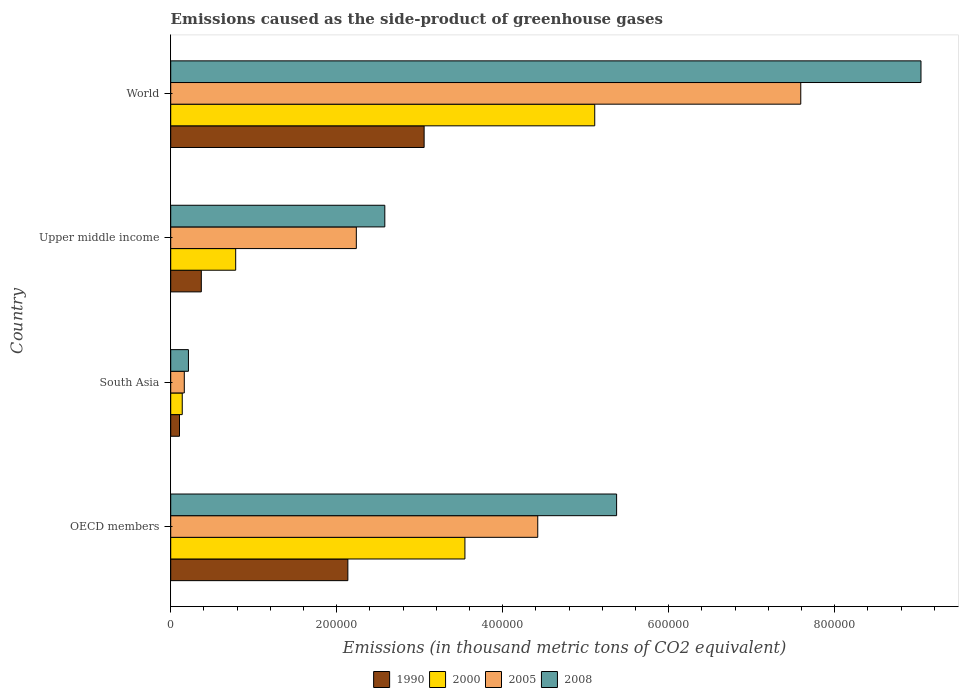How many different coloured bars are there?
Your answer should be very brief. 4. How many groups of bars are there?
Your response must be concise. 4. Are the number of bars on each tick of the Y-axis equal?
Your answer should be very brief. Yes. How many bars are there on the 2nd tick from the top?
Offer a very short reply. 4. What is the emissions caused as the side-product of greenhouse gases in 2000 in World?
Give a very brief answer. 5.11e+05. Across all countries, what is the maximum emissions caused as the side-product of greenhouse gases in 1990?
Keep it short and to the point. 3.05e+05. Across all countries, what is the minimum emissions caused as the side-product of greenhouse gases in 2005?
Provide a short and direct response. 1.64e+04. What is the total emissions caused as the side-product of greenhouse gases in 2000 in the graph?
Make the answer very short. 9.58e+05. What is the difference between the emissions caused as the side-product of greenhouse gases in 1990 in Upper middle income and that in World?
Your answer should be compact. -2.68e+05. What is the difference between the emissions caused as the side-product of greenhouse gases in 2005 in South Asia and the emissions caused as the side-product of greenhouse gases in 1990 in Upper middle income?
Keep it short and to the point. -2.05e+04. What is the average emissions caused as the side-product of greenhouse gases in 2005 per country?
Provide a short and direct response. 3.60e+05. What is the difference between the emissions caused as the side-product of greenhouse gases in 2008 and emissions caused as the side-product of greenhouse gases in 2000 in South Asia?
Ensure brevity in your answer.  7460.6. In how many countries, is the emissions caused as the side-product of greenhouse gases in 1990 greater than 680000 thousand metric tons?
Your answer should be compact. 0. What is the ratio of the emissions caused as the side-product of greenhouse gases in 2005 in South Asia to that in World?
Your answer should be very brief. 0.02. What is the difference between the highest and the second highest emissions caused as the side-product of greenhouse gases in 2005?
Give a very brief answer. 3.17e+05. What is the difference between the highest and the lowest emissions caused as the side-product of greenhouse gases in 1990?
Offer a very short reply. 2.95e+05. In how many countries, is the emissions caused as the side-product of greenhouse gases in 1990 greater than the average emissions caused as the side-product of greenhouse gases in 1990 taken over all countries?
Provide a succinct answer. 2. Is the sum of the emissions caused as the side-product of greenhouse gases in 2008 in OECD members and World greater than the maximum emissions caused as the side-product of greenhouse gases in 2000 across all countries?
Your answer should be compact. Yes. What does the 1st bar from the top in OECD members represents?
Keep it short and to the point. 2008. What does the 4th bar from the bottom in Upper middle income represents?
Offer a very short reply. 2008. Is it the case that in every country, the sum of the emissions caused as the side-product of greenhouse gases in 1990 and emissions caused as the side-product of greenhouse gases in 2000 is greater than the emissions caused as the side-product of greenhouse gases in 2005?
Keep it short and to the point. No. How many bars are there?
Give a very brief answer. 16. Are all the bars in the graph horizontal?
Keep it short and to the point. Yes. How many countries are there in the graph?
Make the answer very short. 4. Does the graph contain any zero values?
Keep it short and to the point. No. Where does the legend appear in the graph?
Make the answer very short. Bottom center. How are the legend labels stacked?
Your answer should be compact. Horizontal. What is the title of the graph?
Your answer should be compact. Emissions caused as the side-product of greenhouse gases. Does "1976" appear as one of the legend labels in the graph?
Make the answer very short. No. What is the label or title of the X-axis?
Give a very brief answer. Emissions (in thousand metric tons of CO2 equivalent). What is the Emissions (in thousand metric tons of CO2 equivalent) of 1990 in OECD members?
Your answer should be very brief. 2.13e+05. What is the Emissions (in thousand metric tons of CO2 equivalent) of 2000 in OECD members?
Offer a very short reply. 3.54e+05. What is the Emissions (in thousand metric tons of CO2 equivalent) in 2005 in OECD members?
Provide a succinct answer. 4.42e+05. What is the Emissions (in thousand metric tons of CO2 equivalent) of 2008 in OECD members?
Your answer should be compact. 5.37e+05. What is the Emissions (in thousand metric tons of CO2 equivalent) of 1990 in South Asia?
Ensure brevity in your answer.  1.06e+04. What is the Emissions (in thousand metric tons of CO2 equivalent) of 2000 in South Asia?
Your answer should be very brief. 1.39e+04. What is the Emissions (in thousand metric tons of CO2 equivalent) in 2005 in South Asia?
Provide a succinct answer. 1.64e+04. What is the Emissions (in thousand metric tons of CO2 equivalent) of 2008 in South Asia?
Keep it short and to the point. 2.14e+04. What is the Emissions (in thousand metric tons of CO2 equivalent) in 1990 in Upper middle income?
Your response must be concise. 3.69e+04. What is the Emissions (in thousand metric tons of CO2 equivalent) in 2000 in Upper middle income?
Your answer should be very brief. 7.83e+04. What is the Emissions (in thousand metric tons of CO2 equivalent) in 2005 in Upper middle income?
Keep it short and to the point. 2.24e+05. What is the Emissions (in thousand metric tons of CO2 equivalent) in 2008 in Upper middle income?
Give a very brief answer. 2.58e+05. What is the Emissions (in thousand metric tons of CO2 equivalent) in 1990 in World?
Your answer should be compact. 3.05e+05. What is the Emissions (in thousand metric tons of CO2 equivalent) of 2000 in World?
Offer a terse response. 5.11e+05. What is the Emissions (in thousand metric tons of CO2 equivalent) in 2005 in World?
Your answer should be compact. 7.59e+05. What is the Emissions (in thousand metric tons of CO2 equivalent) in 2008 in World?
Your answer should be very brief. 9.04e+05. Across all countries, what is the maximum Emissions (in thousand metric tons of CO2 equivalent) in 1990?
Offer a very short reply. 3.05e+05. Across all countries, what is the maximum Emissions (in thousand metric tons of CO2 equivalent) in 2000?
Keep it short and to the point. 5.11e+05. Across all countries, what is the maximum Emissions (in thousand metric tons of CO2 equivalent) in 2005?
Provide a succinct answer. 7.59e+05. Across all countries, what is the maximum Emissions (in thousand metric tons of CO2 equivalent) in 2008?
Your answer should be very brief. 9.04e+05. Across all countries, what is the minimum Emissions (in thousand metric tons of CO2 equivalent) of 1990?
Ensure brevity in your answer.  1.06e+04. Across all countries, what is the minimum Emissions (in thousand metric tons of CO2 equivalent) of 2000?
Keep it short and to the point. 1.39e+04. Across all countries, what is the minimum Emissions (in thousand metric tons of CO2 equivalent) in 2005?
Give a very brief answer. 1.64e+04. Across all countries, what is the minimum Emissions (in thousand metric tons of CO2 equivalent) in 2008?
Your response must be concise. 2.14e+04. What is the total Emissions (in thousand metric tons of CO2 equivalent) in 1990 in the graph?
Your answer should be compact. 5.66e+05. What is the total Emissions (in thousand metric tons of CO2 equivalent) of 2000 in the graph?
Give a very brief answer. 9.58e+05. What is the total Emissions (in thousand metric tons of CO2 equivalent) in 2005 in the graph?
Your answer should be very brief. 1.44e+06. What is the total Emissions (in thousand metric tons of CO2 equivalent) in 2008 in the graph?
Give a very brief answer. 1.72e+06. What is the difference between the Emissions (in thousand metric tons of CO2 equivalent) of 1990 in OECD members and that in South Asia?
Your answer should be very brief. 2.03e+05. What is the difference between the Emissions (in thousand metric tons of CO2 equivalent) of 2000 in OECD members and that in South Asia?
Your answer should be compact. 3.41e+05. What is the difference between the Emissions (in thousand metric tons of CO2 equivalent) in 2005 in OECD members and that in South Asia?
Offer a very short reply. 4.26e+05. What is the difference between the Emissions (in thousand metric tons of CO2 equivalent) of 2008 in OECD members and that in South Asia?
Provide a short and direct response. 5.16e+05. What is the difference between the Emissions (in thousand metric tons of CO2 equivalent) in 1990 in OECD members and that in Upper middle income?
Your response must be concise. 1.77e+05. What is the difference between the Emissions (in thousand metric tons of CO2 equivalent) of 2000 in OECD members and that in Upper middle income?
Your answer should be very brief. 2.76e+05. What is the difference between the Emissions (in thousand metric tons of CO2 equivalent) in 2005 in OECD members and that in Upper middle income?
Your answer should be compact. 2.19e+05. What is the difference between the Emissions (in thousand metric tons of CO2 equivalent) in 2008 in OECD members and that in Upper middle income?
Give a very brief answer. 2.79e+05. What is the difference between the Emissions (in thousand metric tons of CO2 equivalent) in 1990 in OECD members and that in World?
Provide a succinct answer. -9.19e+04. What is the difference between the Emissions (in thousand metric tons of CO2 equivalent) of 2000 in OECD members and that in World?
Provide a succinct answer. -1.56e+05. What is the difference between the Emissions (in thousand metric tons of CO2 equivalent) of 2005 in OECD members and that in World?
Ensure brevity in your answer.  -3.17e+05. What is the difference between the Emissions (in thousand metric tons of CO2 equivalent) of 2008 in OECD members and that in World?
Give a very brief answer. -3.67e+05. What is the difference between the Emissions (in thousand metric tons of CO2 equivalent) in 1990 in South Asia and that in Upper middle income?
Give a very brief answer. -2.63e+04. What is the difference between the Emissions (in thousand metric tons of CO2 equivalent) of 2000 in South Asia and that in Upper middle income?
Make the answer very short. -6.44e+04. What is the difference between the Emissions (in thousand metric tons of CO2 equivalent) of 2005 in South Asia and that in Upper middle income?
Provide a short and direct response. -2.07e+05. What is the difference between the Emissions (in thousand metric tons of CO2 equivalent) of 2008 in South Asia and that in Upper middle income?
Offer a very short reply. -2.37e+05. What is the difference between the Emissions (in thousand metric tons of CO2 equivalent) of 1990 in South Asia and that in World?
Make the answer very short. -2.95e+05. What is the difference between the Emissions (in thousand metric tons of CO2 equivalent) of 2000 in South Asia and that in World?
Keep it short and to the point. -4.97e+05. What is the difference between the Emissions (in thousand metric tons of CO2 equivalent) of 2005 in South Asia and that in World?
Give a very brief answer. -7.43e+05. What is the difference between the Emissions (in thousand metric tons of CO2 equivalent) of 2008 in South Asia and that in World?
Your answer should be compact. -8.83e+05. What is the difference between the Emissions (in thousand metric tons of CO2 equivalent) in 1990 in Upper middle income and that in World?
Provide a succinct answer. -2.68e+05. What is the difference between the Emissions (in thousand metric tons of CO2 equivalent) of 2000 in Upper middle income and that in World?
Your answer should be very brief. -4.33e+05. What is the difference between the Emissions (in thousand metric tons of CO2 equivalent) of 2005 in Upper middle income and that in World?
Your answer should be very brief. -5.36e+05. What is the difference between the Emissions (in thousand metric tons of CO2 equivalent) of 2008 in Upper middle income and that in World?
Ensure brevity in your answer.  -6.46e+05. What is the difference between the Emissions (in thousand metric tons of CO2 equivalent) in 1990 in OECD members and the Emissions (in thousand metric tons of CO2 equivalent) in 2000 in South Asia?
Your answer should be very brief. 2.00e+05. What is the difference between the Emissions (in thousand metric tons of CO2 equivalent) of 1990 in OECD members and the Emissions (in thousand metric tons of CO2 equivalent) of 2005 in South Asia?
Provide a succinct answer. 1.97e+05. What is the difference between the Emissions (in thousand metric tons of CO2 equivalent) of 1990 in OECD members and the Emissions (in thousand metric tons of CO2 equivalent) of 2008 in South Asia?
Your answer should be compact. 1.92e+05. What is the difference between the Emissions (in thousand metric tons of CO2 equivalent) of 2000 in OECD members and the Emissions (in thousand metric tons of CO2 equivalent) of 2005 in South Asia?
Ensure brevity in your answer.  3.38e+05. What is the difference between the Emissions (in thousand metric tons of CO2 equivalent) in 2000 in OECD members and the Emissions (in thousand metric tons of CO2 equivalent) in 2008 in South Asia?
Offer a very short reply. 3.33e+05. What is the difference between the Emissions (in thousand metric tons of CO2 equivalent) of 2005 in OECD members and the Emissions (in thousand metric tons of CO2 equivalent) of 2008 in South Asia?
Ensure brevity in your answer.  4.21e+05. What is the difference between the Emissions (in thousand metric tons of CO2 equivalent) in 1990 in OECD members and the Emissions (in thousand metric tons of CO2 equivalent) in 2000 in Upper middle income?
Make the answer very short. 1.35e+05. What is the difference between the Emissions (in thousand metric tons of CO2 equivalent) of 1990 in OECD members and the Emissions (in thousand metric tons of CO2 equivalent) of 2005 in Upper middle income?
Provide a succinct answer. -1.02e+04. What is the difference between the Emissions (in thousand metric tons of CO2 equivalent) of 1990 in OECD members and the Emissions (in thousand metric tons of CO2 equivalent) of 2008 in Upper middle income?
Keep it short and to the point. -4.45e+04. What is the difference between the Emissions (in thousand metric tons of CO2 equivalent) of 2000 in OECD members and the Emissions (in thousand metric tons of CO2 equivalent) of 2005 in Upper middle income?
Offer a very short reply. 1.31e+05. What is the difference between the Emissions (in thousand metric tons of CO2 equivalent) of 2000 in OECD members and the Emissions (in thousand metric tons of CO2 equivalent) of 2008 in Upper middle income?
Your response must be concise. 9.65e+04. What is the difference between the Emissions (in thousand metric tons of CO2 equivalent) of 2005 in OECD members and the Emissions (in thousand metric tons of CO2 equivalent) of 2008 in Upper middle income?
Provide a short and direct response. 1.84e+05. What is the difference between the Emissions (in thousand metric tons of CO2 equivalent) of 1990 in OECD members and the Emissions (in thousand metric tons of CO2 equivalent) of 2000 in World?
Your answer should be compact. -2.97e+05. What is the difference between the Emissions (in thousand metric tons of CO2 equivalent) in 1990 in OECD members and the Emissions (in thousand metric tons of CO2 equivalent) in 2005 in World?
Provide a succinct answer. -5.46e+05. What is the difference between the Emissions (in thousand metric tons of CO2 equivalent) of 1990 in OECD members and the Emissions (in thousand metric tons of CO2 equivalent) of 2008 in World?
Provide a short and direct response. -6.91e+05. What is the difference between the Emissions (in thousand metric tons of CO2 equivalent) of 2000 in OECD members and the Emissions (in thousand metric tons of CO2 equivalent) of 2005 in World?
Offer a terse response. -4.05e+05. What is the difference between the Emissions (in thousand metric tons of CO2 equivalent) in 2000 in OECD members and the Emissions (in thousand metric tons of CO2 equivalent) in 2008 in World?
Your response must be concise. -5.49e+05. What is the difference between the Emissions (in thousand metric tons of CO2 equivalent) in 2005 in OECD members and the Emissions (in thousand metric tons of CO2 equivalent) in 2008 in World?
Provide a succinct answer. -4.62e+05. What is the difference between the Emissions (in thousand metric tons of CO2 equivalent) of 1990 in South Asia and the Emissions (in thousand metric tons of CO2 equivalent) of 2000 in Upper middle income?
Offer a terse response. -6.77e+04. What is the difference between the Emissions (in thousand metric tons of CO2 equivalent) in 1990 in South Asia and the Emissions (in thousand metric tons of CO2 equivalent) in 2005 in Upper middle income?
Your answer should be very brief. -2.13e+05. What is the difference between the Emissions (in thousand metric tons of CO2 equivalent) in 1990 in South Asia and the Emissions (in thousand metric tons of CO2 equivalent) in 2008 in Upper middle income?
Provide a short and direct response. -2.47e+05. What is the difference between the Emissions (in thousand metric tons of CO2 equivalent) of 2000 in South Asia and the Emissions (in thousand metric tons of CO2 equivalent) of 2005 in Upper middle income?
Provide a short and direct response. -2.10e+05. What is the difference between the Emissions (in thousand metric tons of CO2 equivalent) in 2000 in South Asia and the Emissions (in thousand metric tons of CO2 equivalent) in 2008 in Upper middle income?
Provide a short and direct response. -2.44e+05. What is the difference between the Emissions (in thousand metric tons of CO2 equivalent) in 2005 in South Asia and the Emissions (in thousand metric tons of CO2 equivalent) in 2008 in Upper middle income?
Provide a succinct answer. -2.42e+05. What is the difference between the Emissions (in thousand metric tons of CO2 equivalent) of 1990 in South Asia and the Emissions (in thousand metric tons of CO2 equivalent) of 2000 in World?
Your response must be concise. -5.00e+05. What is the difference between the Emissions (in thousand metric tons of CO2 equivalent) of 1990 in South Asia and the Emissions (in thousand metric tons of CO2 equivalent) of 2005 in World?
Give a very brief answer. -7.49e+05. What is the difference between the Emissions (in thousand metric tons of CO2 equivalent) of 1990 in South Asia and the Emissions (in thousand metric tons of CO2 equivalent) of 2008 in World?
Make the answer very short. -8.93e+05. What is the difference between the Emissions (in thousand metric tons of CO2 equivalent) of 2000 in South Asia and the Emissions (in thousand metric tons of CO2 equivalent) of 2005 in World?
Your response must be concise. -7.45e+05. What is the difference between the Emissions (in thousand metric tons of CO2 equivalent) of 2000 in South Asia and the Emissions (in thousand metric tons of CO2 equivalent) of 2008 in World?
Offer a very short reply. -8.90e+05. What is the difference between the Emissions (in thousand metric tons of CO2 equivalent) of 2005 in South Asia and the Emissions (in thousand metric tons of CO2 equivalent) of 2008 in World?
Your answer should be very brief. -8.88e+05. What is the difference between the Emissions (in thousand metric tons of CO2 equivalent) of 1990 in Upper middle income and the Emissions (in thousand metric tons of CO2 equivalent) of 2000 in World?
Your response must be concise. -4.74e+05. What is the difference between the Emissions (in thousand metric tons of CO2 equivalent) of 1990 in Upper middle income and the Emissions (in thousand metric tons of CO2 equivalent) of 2005 in World?
Give a very brief answer. -7.22e+05. What is the difference between the Emissions (in thousand metric tons of CO2 equivalent) of 1990 in Upper middle income and the Emissions (in thousand metric tons of CO2 equivalent) of 2008 in World?
Provide a succinct answer. -8.67e+05. What is the difference between the Emissions (in thousand metric tons of CO2 equivalent) of 2000 in Upper middle income and the Emissions (in thousand metric tons of CO2 equivalent) of 2005 in World?
Provide a short and direct response. -6.81e+05. What is the difference between the Emissions (in thousand metric tons of CO2 equivalent) of 2000 in Upper middle income and the Emissions (in thousand metric tons of CO2 equivalent) of 2008 in World?
Your response must be concise. -8.26e+05. What is the difference between the Emissions (in thousand metric tons of CO2 equivalent) of 2005 in Upper middle income and the Emissions (in thousand metric tons of CO2 equivalent) of 2008 in World?
Ensure brevity in your answer.  -6.80e+05. What is the average Emissions (in thousand metric tons of CO2 equivalent) in 1990 per country?
Your response must be concise. 1.42e+05. What is the average Emissions (in thousand metric tons of CO2 equivalent) in 2000 per country?
Your answer should be very brief. 2.39e+05. What is the average Emissions (in thousand metric tons of CO2 equivalent) in 2005 per country?
Make the answer very short. 3.60e+05. What is the average Emissions (in thousand metric tons of CO2 equivalent) in 2008 per country?
Offer a very short reply. 4.30e+05. What is the difference between the Emissions (in thousand metric tons of CO2 equivalent) of 1990 and Emissions (in thousand metric tons of CO2 equivalent) of 2000 in OECD members?
Give a very brief answer. -1.41e+05. What is the difference between the Emissions (in thousand metric tons of CO2 equivalent) in 1990 and Emissions (in thousand metric tons of CO2 equivalent) in 2005 in OECD members?
Ensure brevity in your answer.  -2.29e+05. What is the difference between the Emissions (in thousand metric tons of CO2 equivalent) of 1990 and Emissions (in thousand metric tons of CO2 equivalent) of 2008 in OECD members?
Offer a terse response. -3.24e+05. What is the difference between the Emissions (in thousand metric tons of CO2 equivalent) in 2000 and Emissions (in thousand metric tons of CO2 equivalent) in 2005 in OECD members?
Provide a short and direct response. -8.78e+04. What is the difference between the Emissions (in thousand metric tons of CO2 equivalent) of 2000 and Emissions (in thousand metric tons of CO2 equivalent) of 2008 in OECD members?
Your response must be concise. -1.83e+05. What is the difference between the Emissions (in thousand metric tons of CO2 equivalent) of 2005 and Emissions (in thousand metric tons of CO2 equivalent) of 2008 in OECD members?
Provide a short and direct response. -9.50e+04. What is the difference between the Emissions (in thousand metric tons of CO2 equivalent) of 1990 and Emissions (in thousand metric tons of CO2 equivalent) of 2000 in South Asia?
Give a very brief answer. -3325.3. What is the difference between the Emissions (in thousand metric tons of CO2 equivalent) in 1990 and Emissions (in thousand metric tons of CO2 equivalent) in 2005 in South Asia?
Provide a short and direct response. -5786.5. What is the difference between the Emissions (in thousand metric tons of CO2 equivalent) in 1990 and Emissions (in thousand metric tons of CO2 equivalent) in 2008 in South Asia?
Provide a succinct answer. -1.08e+04. What is the difference between the Emissions (in thousand metric tons of CO2 equivalent) in 2000 and Emissions (in thousand metric tons of CO2 equivalent) in 2005 in South Asia?
Give a very brief answer. -2461.2. What is the difference between the Emissions (in thousand metric tons of CO2 equivalent) in 2000 and Emissions (in thousand metric tons of CO2 equivalent) in 2008 in South Asia?
Give a very brief answer. -7460.6. What is the difference between the Emissions (in thousand metric tons of CO2 equivalent) in 2005 and Emissions (in thousand metric tons of CO2 equivalent) in 2008 in South Asia?
Your response must be concise. -4999.4. What is the difference between the Emissions (in thousand metric tons of CO2 equivalent) in 1990 and Emissions (in thousand metric tons of CO2 equivalent) in 2000 in Upper middle income?
Give a very brief answer. -4.14e+04. What is the difference between the Emissions (in thousand metric tons of CO2 equivalent) of 1990 and Emissions (in thousand metric tons of CO2 equivalent) of 2005 in Upper middle income?
Provide a succinct answer. -1.87e+05. What is the difference between the Emissions (in thousand metric tons of CO2 equivalent) of 1990 and Emissions (in thousand metric tons of CO2 equivalent) of 2008 in Upper middle income?
Your answer should be very brief. -2.21e+05. What is the difference between the Emissions (in thousand metric tons of CO2 equivalent) of 2000 and Emissions (in thousand metric tons of CO2 equivalent) of 2005 in Upper middle income?
Your answer should be compact. -1.45e+05. What is the difference between the Emissions (in thousand metric tons of CO2 equivalent) in 2000 and Emissions (in thousand metric tons of CO2 equivalent) in 2008 in Upper middle income?
Give a very brief answer. -1.80e+05. What is the difference between the Emissions (in thousand metric tons of CO2 equivalent) in 2005 and Emissions (in thousand metric tons of CO2 equivalent) in 2008 in Upper middle income?
Your response must be concise. -3.43e+04. What is the difference between the Emissions (in thousand metric tons of CO2 equivalent) of 1990 and Emissions (in thousand metric tons of CO2 equivalent) of 2000 in World?
Offer a very short reply. -2.06e+05. What is the difference between the Emissions (in thousand metric tons of CO2 equivalent) of 1990 and Emissions (in thousand metric tons of CO2 equivalent) of 2005 in World?
Make the answer very short. -4.54e+05. What is the difference between the Emissions (in thousand metric tons of CO2 equivalent) of 1990 and Emissions (in thousand metric tons of CO2 equivalent) of 2008 in World?
Make the answer very short. -5.99e+05. What is the difference between the Emissions (in thousand metric tons of CO2 equivalent) of 2000 and Emissions (in thousand metric tons of CO2 equivalent) of 2005 in World?
Keep it short and to the point. -2.48e+05. What is the difference between the Emissions (in thousand metric tons of CO2 equivalent) in 2000 and Emissions (in thousand metric tons of CO2 equivalent) in 2008 in World?
Offer a very short reply. -3.93e+05. What is the difference between the Emissions (in thousand metric tons of CO2 equivalent) of 2005 and Emissions (in thousand metric tons of CO2 equivalent) of 2008 in World?
Provide a succinct answer. -1.45e+05. What is the ratio of the Emissions (in thousand metric tons of CO2 equivalent) in 1990 in OECD members to that in South Asia?
Give a very brief answer. 20.19. What is the ratio of the Emissions (in thousand metric tons of CO2 equivalent) in 2000 in OECD members to that in South Asia?
Ensure brevity in your answer.  25.51. What is the ratio of the Emissions (in thousand metric tons of CO2 equivalent) in 2005 in OECD members to that in South Asia?
Your answer should be very brief. 27.03. What is the ratio of the Emissions (in thousand metric tons of CO2 equivalent) in 2008 in OECD members to that in South Asia?
Provide a short and direct response. 25.15. What is the ratio of the Emissions (in thousand metric tons of CO2 equivalent) in 1990 in OECD members to that in Upper middle income?
Make the answer very short. 5.79. What is the ratio of the Emissions (in thousand metric tons of CO2 equivalent) of 2000 in OECD members to that in Upper middle income?
Offer a terse response. 4.53. What is the ratio of the Emissions (in thousand metric tons of CO2 equivalent) of 2005 in OECD members to that in Upper middle income?
Give a very brief answer. 1.98. What is the ratio of the Emissions (in thousand metric tons of CO2 equivalent) of 2008 in OECD members to that in Upper middle income?
Offer a very short reply. 2.08. What is the ratio of the Emissions (in thousand metric tons of CO2 equivalent) in 1990 in OECD members to that in World?
Your answer should be very brief. 0.7. What is the ratio of the Emissions (in thousand metric tons of CO2 equivalent) of 2000 in OECD members to that in World?
Provide a short and direct response. 0.69. What is the ratio of the Emissions (in thousand metric tons of CO2 equivalent) of 2005 in OECD members to that in World?
Offer a terse response. 0.58. What is the ratio of the Emissions (in thousand metric tons of CO2 equivalent) in 2008 in OECD members to that in World?
Provide a short and direct response. 0.59. What is the ratio of the Emissions (in thousand metric tons of CO2 equivalent) of 1990 in South Asia to that in Upper middle income?
Ensure brevity in your answer.  0.29. What is the ratio of the Emissions (in thousand metric tons of CO2 equivalent) of 2000 in South Asia to that in Upper middle income?
Your response must be concise. 0.18. What is the ratio of the Emissions (in thousand metric tons of CO2 equivalent) of 2005 in South Asia to that in Upper middle income?
Make the answer very short. 0.07. What is the ratio of the Emissions (in thousand metric tons of CO2 equivalent) of 2008 in South Asia to that in Upper middle income?
Your answer should be very brief. 0.08. What is the ratio of the Emissions (in thousand metric tons of CO2 equivalent) of 1990 in South Asia to that in World?
Provide a short and direct response. 0.03. What is the ratio of the Emissions (in thousand metric tons of CO2 equivalent) of 2000 in South Asia to that in World?
Give a very brief answer. 0.03. What is the ratio of the Emissions (in thousand metric tons of CO2 equivalent) of 2005 in South Asia to that in World?
Make the answer very short. 0.02. What is the ratio of the Emissions (in thousand metric tons of CO2 equivalent) of 2008 in South Asia to that in World?
Provide a succinct answer. 0.02. What is the ratio of the Emissions (in thousand metric tons of CO2 equivalent) of 1990 in Upper middle income to that in World?
Provide a short and direct response. 0.12. What is the ratio of the Emissions (in thousand metric tons of CO2 equivalent) in 2000 in Upper middle income to that in World?
Provide a short and direct response. 0.15. What is the ratio of the Emissions (in thousand metric tons of CO2 equivalent) in 2005 in Upper middle income to that in World?
Give a very brief answer. 0.29. What is the ratio of the Emissions (in thousand metric tons of CO2 equivalent) in 2008 in Upper middle income to that in World?
Ensure brevity in your answer.  0.29. What is the difference between the highest and the second highest Emissions (in thousand metric tons of CO2 equivalent) of 1990?
Your answer should be very brief. 9.19e+04. What is the difference between the highest and the second highest Emissions (in thousand metric tons of CO2 equivalent) in 2000?
Your answer should be very brief. 1.56e+05. What is the difference between the highest and the second highest Emissions (in thousand metric tons of CO2 equivalent) in 2005?
Your answer should be very brief. 3.17e+05. What is the difference between the highest and the second highest Emissions (in thousand metric tons of CO2 equivalent) of 2008?
Provide a succinct answer. 3.67e+05. What is the difference between the highest and the lowest Emissions (in thousand metric tons of CO2 equivalent) in 1990?
Make the answer very short. 2.95e+05. What is the difference between the highest and the lowest Emissions (in thousand metric tons of CO2 equivalent) of 2000?
Keep it short and to the point. 4.97e+05. What is the difference between the highest and the lowest Emissions (in thousand metric tons of CO2 equivalent) of 2005?
Give a very brief answer. 7.43e+05. What is the difference between the highest and the lowest Emissions (in thousand metric tons of CO2 equivalent) of 2008?
Offer a very short reply. 8.83e+05. 